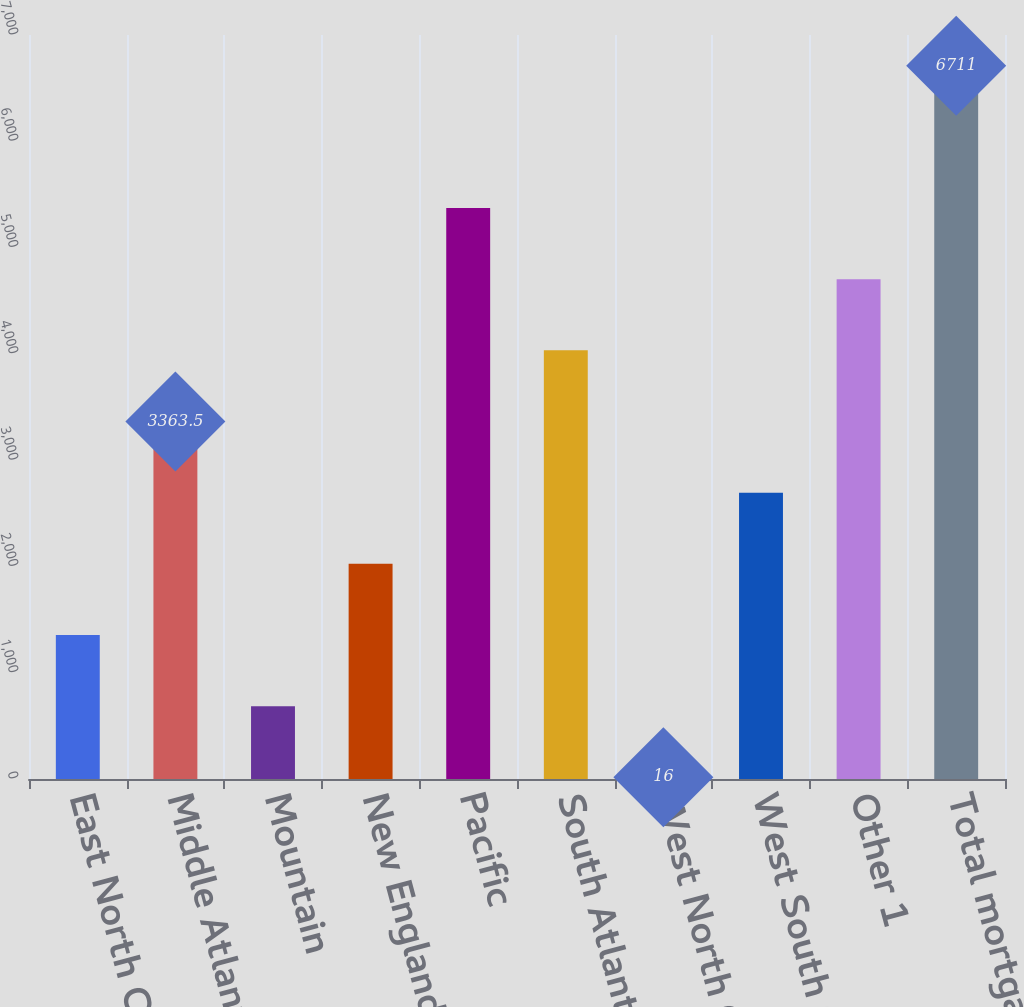Convert chart to OTSL. <chart><loc_0><loc_0><loc_500><loc_500><bar_chart><fcel>East North Central<fcel>Middle Atlantic<fcel>Mountain<fcel>New England<fcel>Pacific<fcel>South Atlantic<fcel>West North Central<fcel>West South Central<fcel>Other 1<fcel>Total mortgage loans<nl><fcel>1355<fcel>3363.5<fcel>685.5<fcel>2024.5<fcel>5372<fcel>4033<fcel>16<fcel>2694<fcel>4702.5<fcel>6711<nl></chart> 